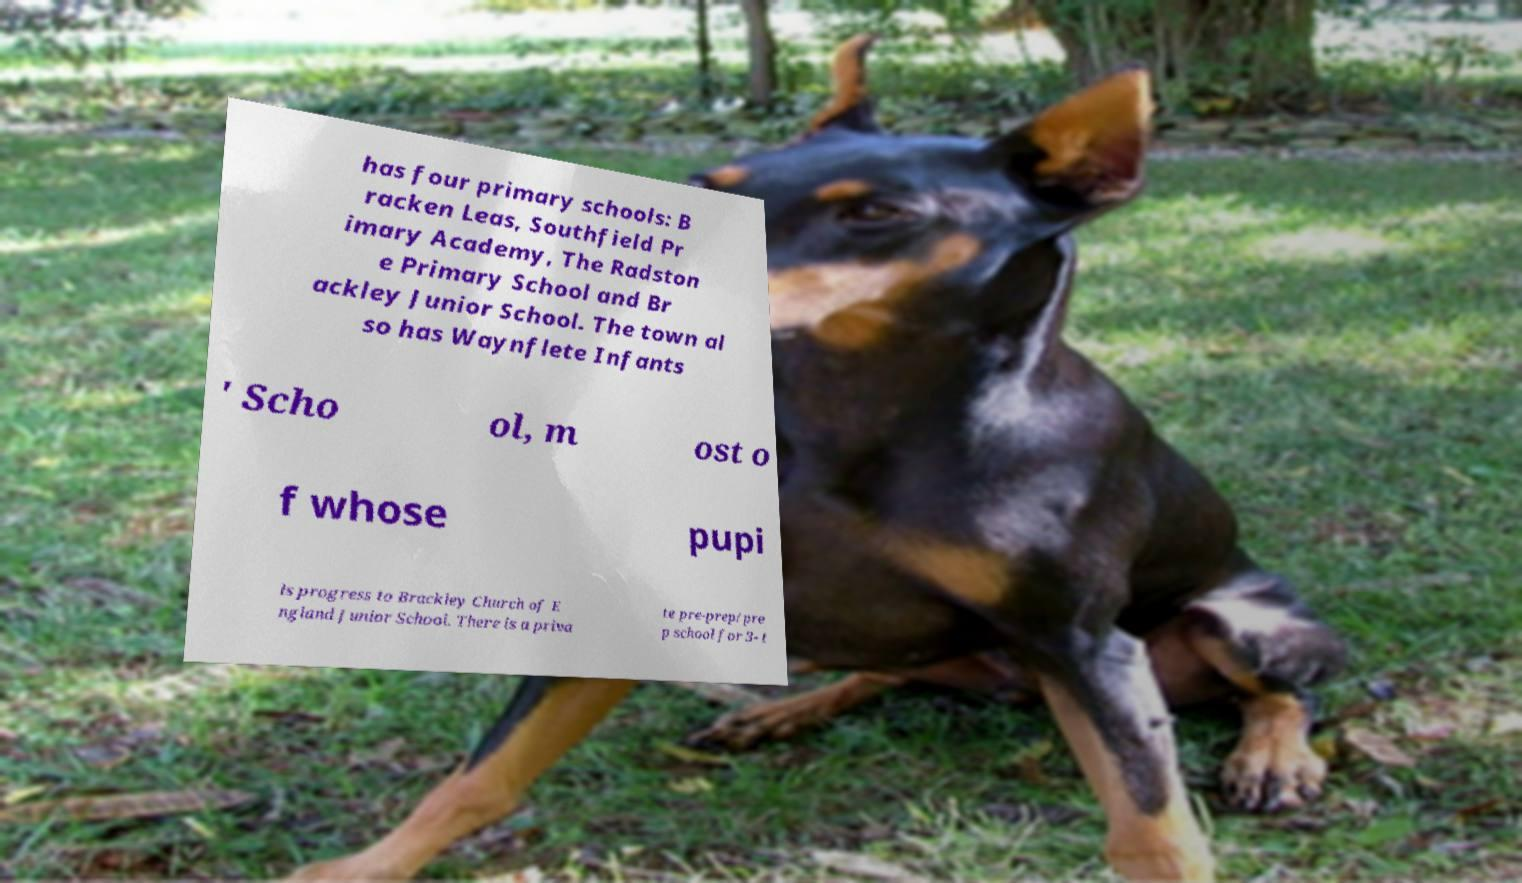I need the written content from this picture converted into text. Can you do that? has four primary schools: B racken Leas, Southfield Pr imary Academy, The Radston e Primary School and Br ackley Junior School. The town al so has Waynflete Infants ' Scho ol, m ost o f whose pupi ls progress to Brackley Church of E ngland Junior School. There is a priva te pre-prep/pre p school for 3- t 